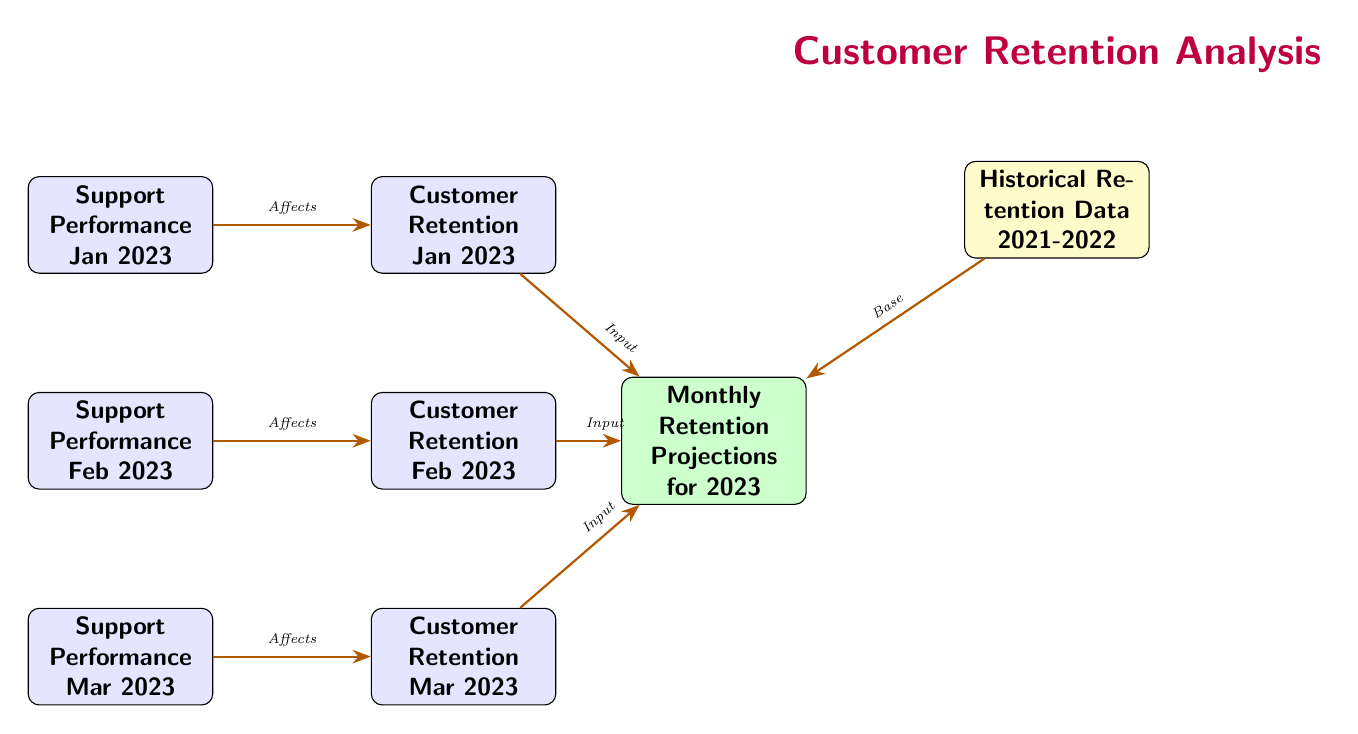What are the months represented in the diagram? The diagram includes three months: January, February, and March of 2023. This information is visible in the nodes labeled as "Customer Retention Jan 2023," "Customer Retention Feb 2023," and "Customer Retention Mar 2023."
Answer: January, February, March Which type of data is shown on the right side of the diagram? On the right side of the diagram, the node labeled "Monthly Retention Projections for 2023" indicates it represents projections related to customer retention for the year 2023.
Answer: Projections How many arrows are pointing toward "Customer Retention Mar 2023"? There is one arrow pointing toward "Customer Retention Mar 2023," coming from "Support Performance Mar 2023." The diagram explicitly shows the flow of impact from support performance to customer retention.
Answer: 1 What is indicated by the arrow that connects "Historical Retention Data 2021-2022" to "Monthly Retention Projections for 2023"? The arrow indicates that the historical data serves as the base for the projections in 2023. This relationship is highlighted by the label "Base" on the directed edge between these two nodes.
Answer: Base How do support performance and customer retention relate in this diagram? Support performance impacts customer retention, as indicated by the arrows that connect each month's support performance to its corresponding customer retention metric. Therefore, without effective support performance, retention may suffer.
Answer: Affects What is the visual style of the nodes in the diagram? The nodes are styled with rounded corners, filled with different colors: blue for support performance and customer retention, green for projections, and yellow for historical data. This distinction helps in quickly identifying the type of data presented in each node.
Answer: Rounded corners, colored fill Which node would you reference for historical data of customer retention? The node labeled "Historical Retention Data 2021-2022" provides information regarding past retention metrics. This is specifically located above the projections node.
Answer: Historical Retention Data 2021-2022 What type of arrows are used in the diagram? The arrows in the diagram are labeled as "-Stealth," which indicates that they are intended to show the direction of influence or effect, particularly how support performance influences customer retention rates.
Answer: -Stealth How many nodes represent customer retention in this diagram? There are three nodes that represent customer retention corresponding to the months of January, February, and March 2023. Each node reflects the retention rate for a specific month.
Answer: 3 